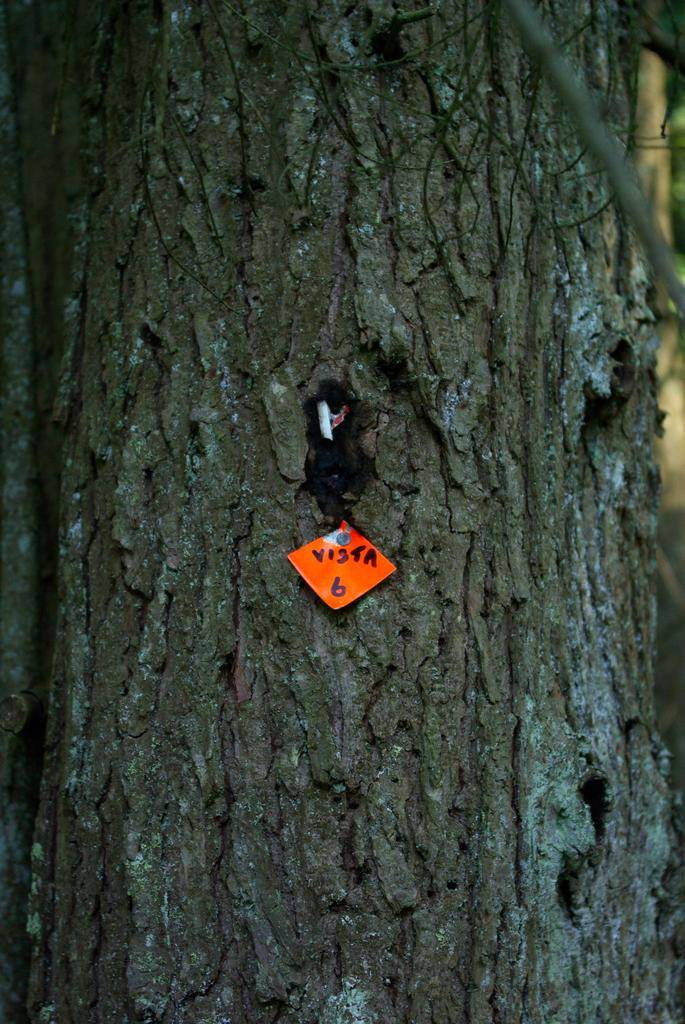What is the main object in the image? There is a tree in the image. What is attached to the tree? There is a paper on the tree. What can be found on the paper? The paper has text and numbers on it. How would you describe the background of the image? The background of the image is blurry. What type of oven can be seen in the image? There is no oven present in the image. What event is taking place in the image? The image does not depict any specific event. 